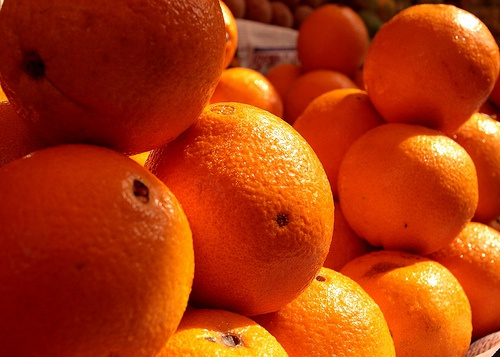Describe the objects in this image and their specific colors. I can see orange in tan, maroon, red, and orange tones, orange in tan, maroon, black, and red tones, orange in tan, brown, red, and orange tones, orange in tan, red, orange, and brown tones, and orange in tan, red, brown, and orange tones in this image. 